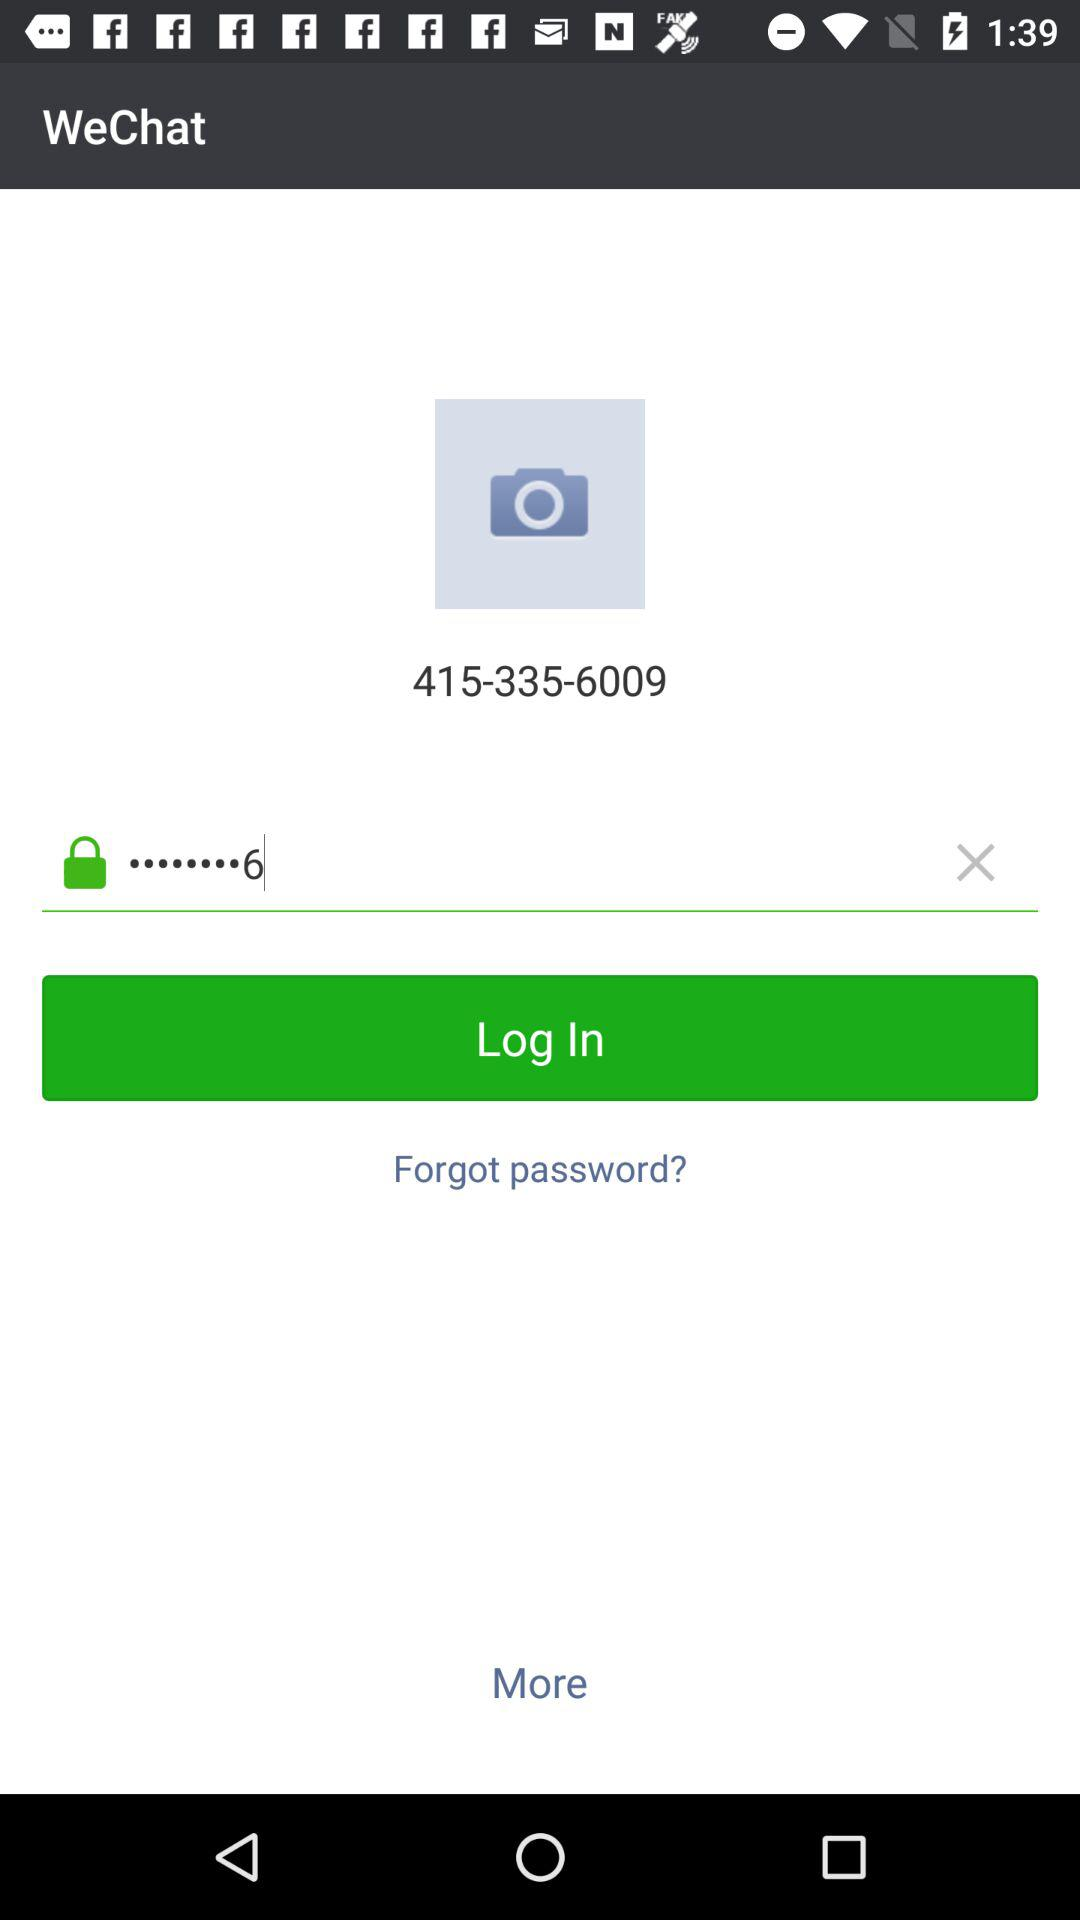What is the user's name?
When the provided information is insufficient, respond with <no answer>. <no answer> 